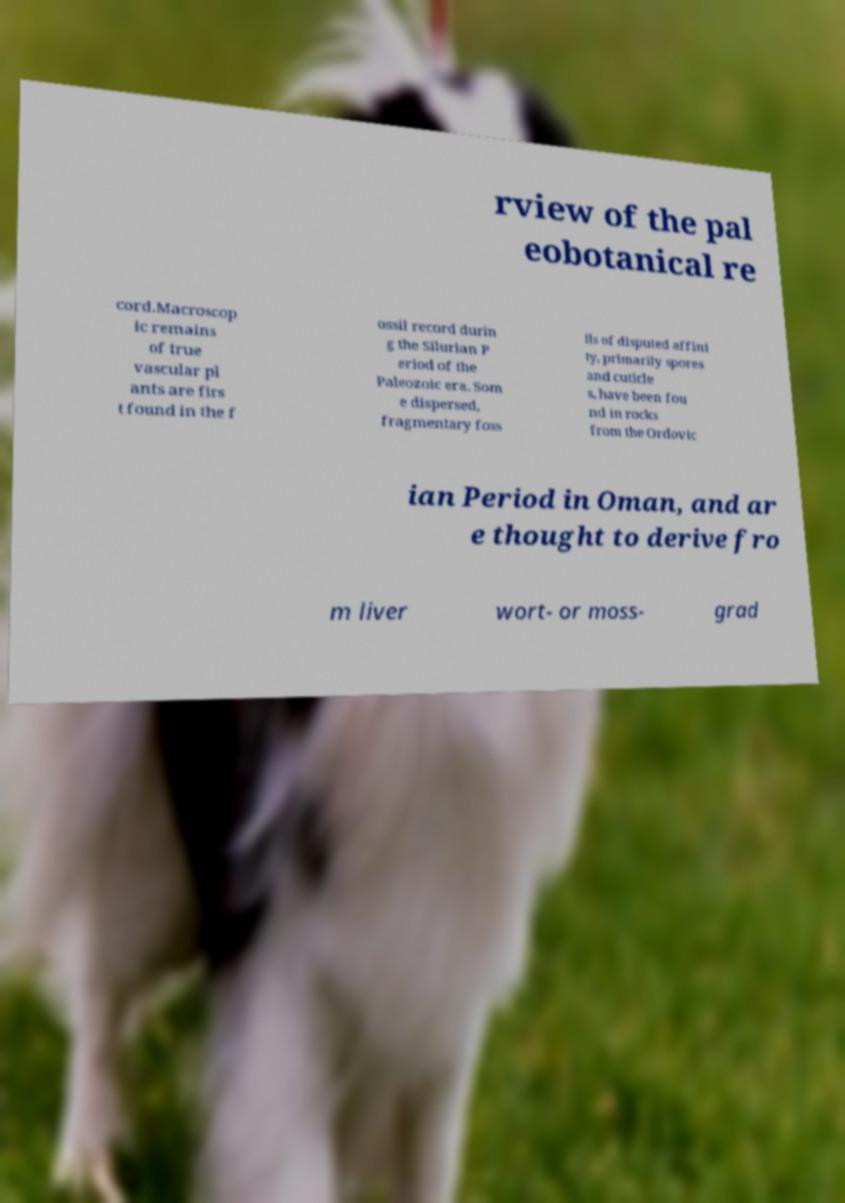Can you read and provide the text displayed in the image?This photo seems to have some interesting text. Can you extract and type it out for me? rview of the pal eobotanical re cord.Macroscop ic remains of true vascular pl ants are firs t found in the f ossil record durin g the Silurian P eriod of the Paleozoic era. Som e dispersed, fragmentary foss ils of disputed affini ty, primarily spores and cuticle s, have been fou nd in rocks from the Ordovic ian Period in Oman, and ar e thought to derive fro m liver wort- or moss- grad 